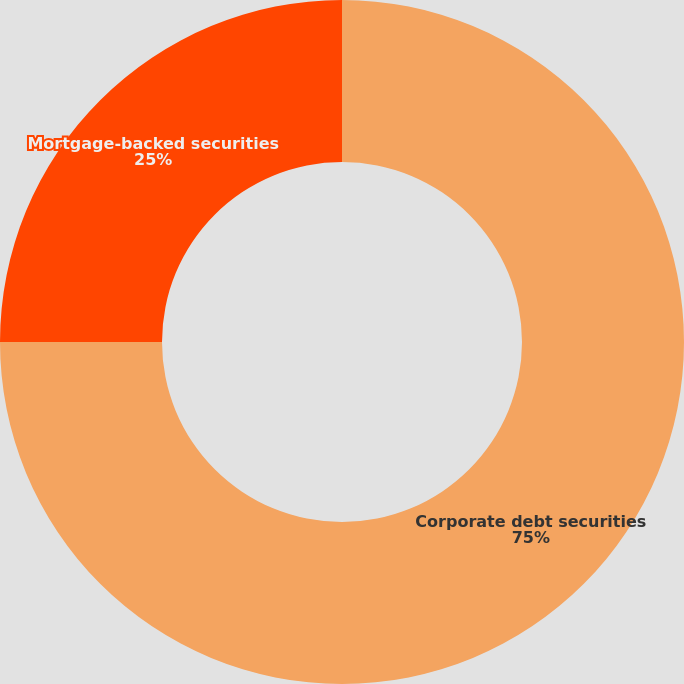Convert chart. <chart><loc_0><loc_0><loc_500><loc_500><pie_chart><fcel>Corporate debt securities<fcel>Mortgage-backed securities<nl><fcel>75.0%<fcel>25.0%<nl></chart> 